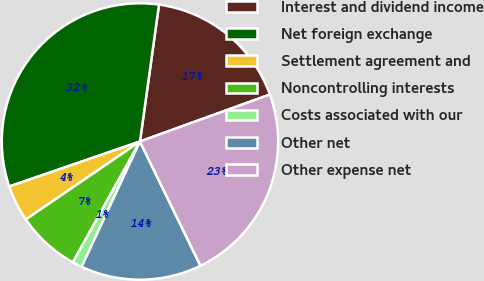Convert chart. <chart><loc_0><loc_0><loc_500><loc_500><pie_chart><fcel>Interest and dividend income<fcel>Net foreign exchange<fcel>Settlement agreement and<fcel>Noncontrolling interests<fcel>Costs associated with our<fcel>Other net<fcel>Other expense net<nl><fcel>17.28%<fcel>32.48%<fcel>4.26%<fcel>7.4%<fcel>1.13%<fcel>14.15%<fcel>23.31%<nl></chart> 